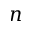Convert formula to latex. <formula><loc_0><loc_0><loc_500><loc_500>n</formula> 